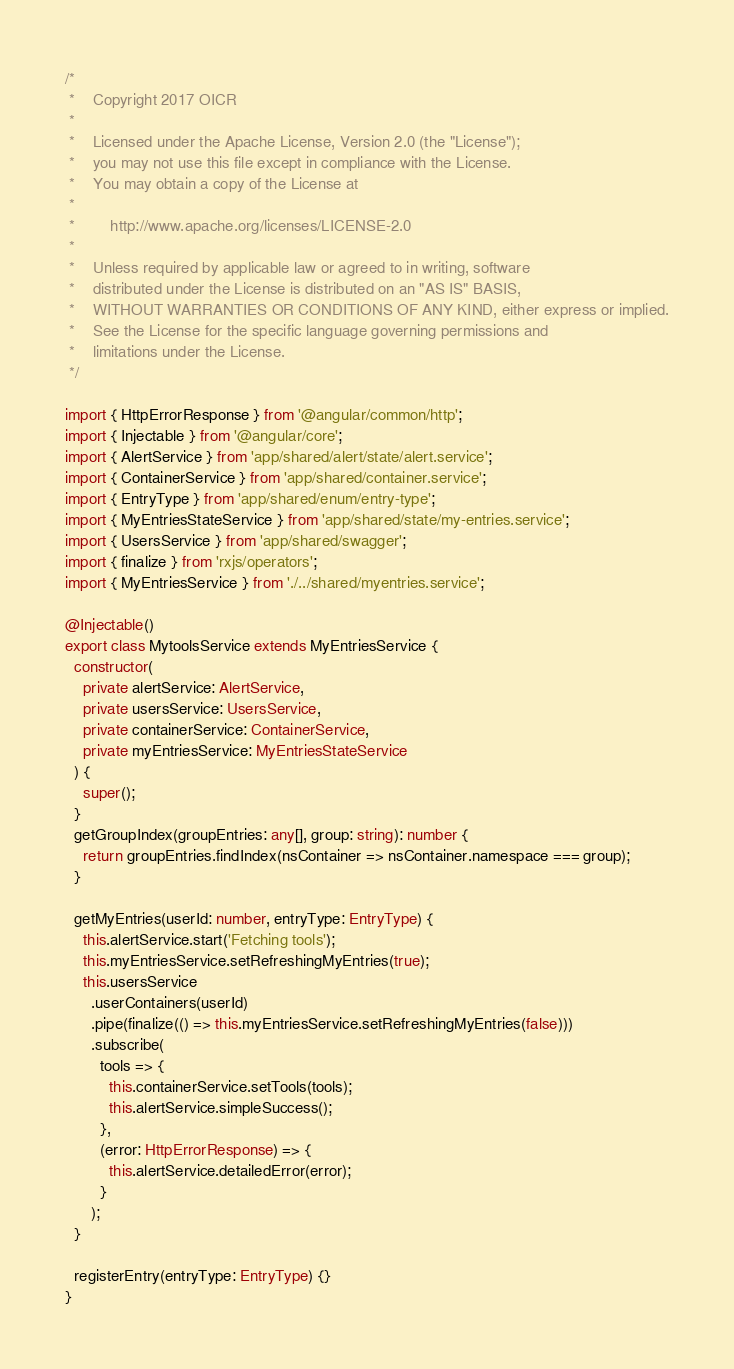Convert code to text. <code><loc_0><loc_0><loc_500><loc_500><_TypeScript_>/*
 *    Copyright 2017 OICR
 *
 *    Licensed under the Apache License, Version 2.0 (the "License");
 *    you may not use this file except in compliance with the License.
 *    You may obtain a copy of the License at
 *
 *        http://www.apache.org/licenses/LICENSE-2.0
 *
 *    Unless required by applicable law or agreed to in writing, software
 *    distributed under the License is distributed on an "AS IS" BASIS,
 *    WITHOUT WARRANTIES OR CONDITIONS OF ANY KIND, either express or implied.
 *    See the License for the specific language governing permissions and
 *    limitations under the License.
 */

import { HttpErrorResponse } from '@angular/common/http';
import { Injectable } from '@angular/core';
import { AlertService } from 'app/shared/alert/state/alert.service';
import { ContainerService } from 'app/shared/container.service';
import { EntryType } from 'app/shared/enum/entry-type';
import { MyEntriesStateService } from 'app/shared/state/my-entries.service';
import { UsersService } from 'app/shared/swagger';
import { finalize } from 'rxjs/operators';
import { MyEntriesService } from './../shared/myentries.service';

@Injectable()
export class MytoolsService extends MyEntriesService {
  constructor(
    private alertService: AlertService,
    private usersService: UsersService,
    private containerService: ContainerService,
    private myEntriesService: MyEntriesStateService
  ) {
    super();
  }
  getGroupIndex(groupEntries: any[], group: string): number {
    return groupEntries.findIndex(nsContainer => nsContainer.namespace === group);
  }

  getMyEntries(userId: number, entryType: EntryType) {
    this.alertService.start('Fetching tools');
    this.myEntriesService.setRefreshingMyEntries(true);
    this.usersService
      .userContainers(userId)
      .pipe(finalize(() => this.myEntriesService.setRefreshingMyEntries(false)))
      .subscribe(
        tools => {
          this.containerService.setTools(tools);
          this.alertService.simpleSuccess();
        },
        (error: HttpErrorResponse) => {
          this.alertService.detailedError(error);
        }
      );
  }

  registerEntry(entryType: EntryType) {}
}
</code> 